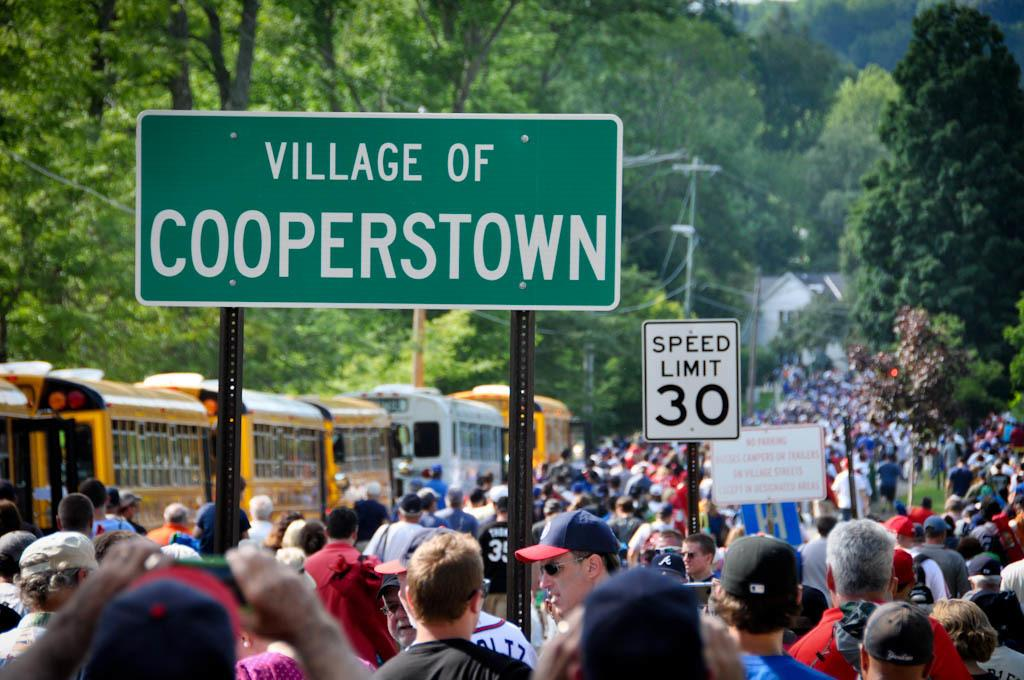What is the main feature of the image? There is a huge crowd in the image. Are there any signs or warnings visible among the crowd? Yes, there are caution boards among the crowd. What can be seen on the left side of the image? There are buses on the left side of the image. What type of natural elements are present around the crowd? There are many trees around the crowd. Can you tell me how many carts are being pulled by the people in the image? There are no carts being pulled by the people in the image. What type of animals are running around the crowd in the image? There are no animals running around the crowd in the image. 